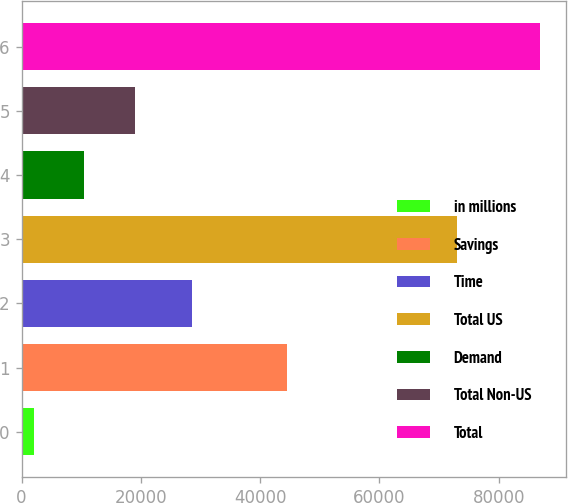<chart> <loc_0><loc_0><loc_500><loc_500><bar_chart><fcel>in millions<fcel>Savings<fcel>Time<fcel>Total US<fcel>Demand<fcel>Total Non-US<fcel>Total<nl><fcel>2015<fcel>44486<fcel>28577<fcel>73063<fcel>10508.3<fcel>19001.6<fcel>86948<nl></chart> 